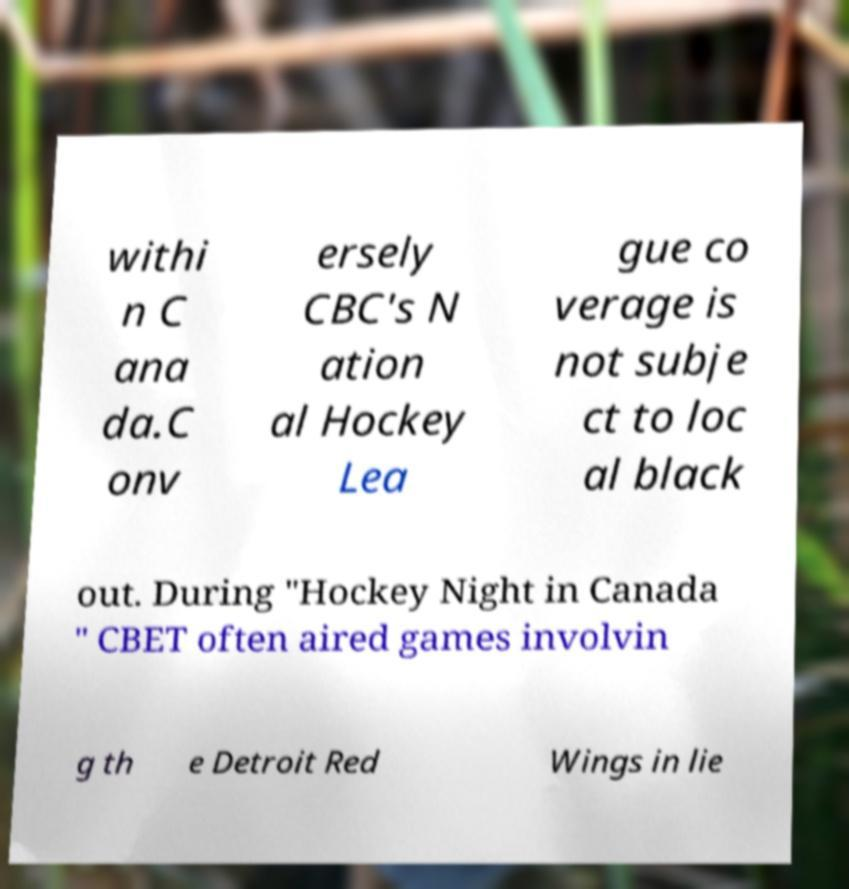Can you read and provide the text displayed in the image?This photo seems to have some interesting text. Can you extract and type it out for me? withi n C ana da.C onv ersely CBC's N ation al Hockey Lea gue co verage is not subje ct to loc al black out. During "Hockey Night in Canada " CBET often aired games involvin g th e Detroit Red Wings in lie 